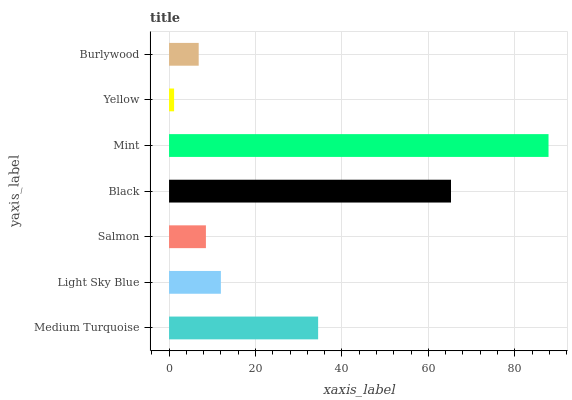Is Yellow the minimum?
Answer yes or no. Yes. Is Mint the maximum?
Answer yes or no. Yes. Is Light Sky Blue the minimum?
Answer yes or no. No. Is Light Sky Blue the maximum?
Answer yes or no. No. Is Medium Turquoise greater than Light Sky Blue?
Answer yes or no. Yes. Is Light Sky Blue less than Medium Turquoise?
Answer yes or no. Yes. Is Light Sky Blue greater than Medium Turquoise?
Answer yes or no. No. Is Medium Turquoise less than Light Sky Blue?
Answer yes or no. No. Is Light Sky Blue the high median?
Answer yes or no. Yes. Is Light Sky Blue the low median?
Answer yes or no. Yes. Is Salmon the high median?
Answer yes or no. No. Is Black the low median?
Answer yes or no. No. 